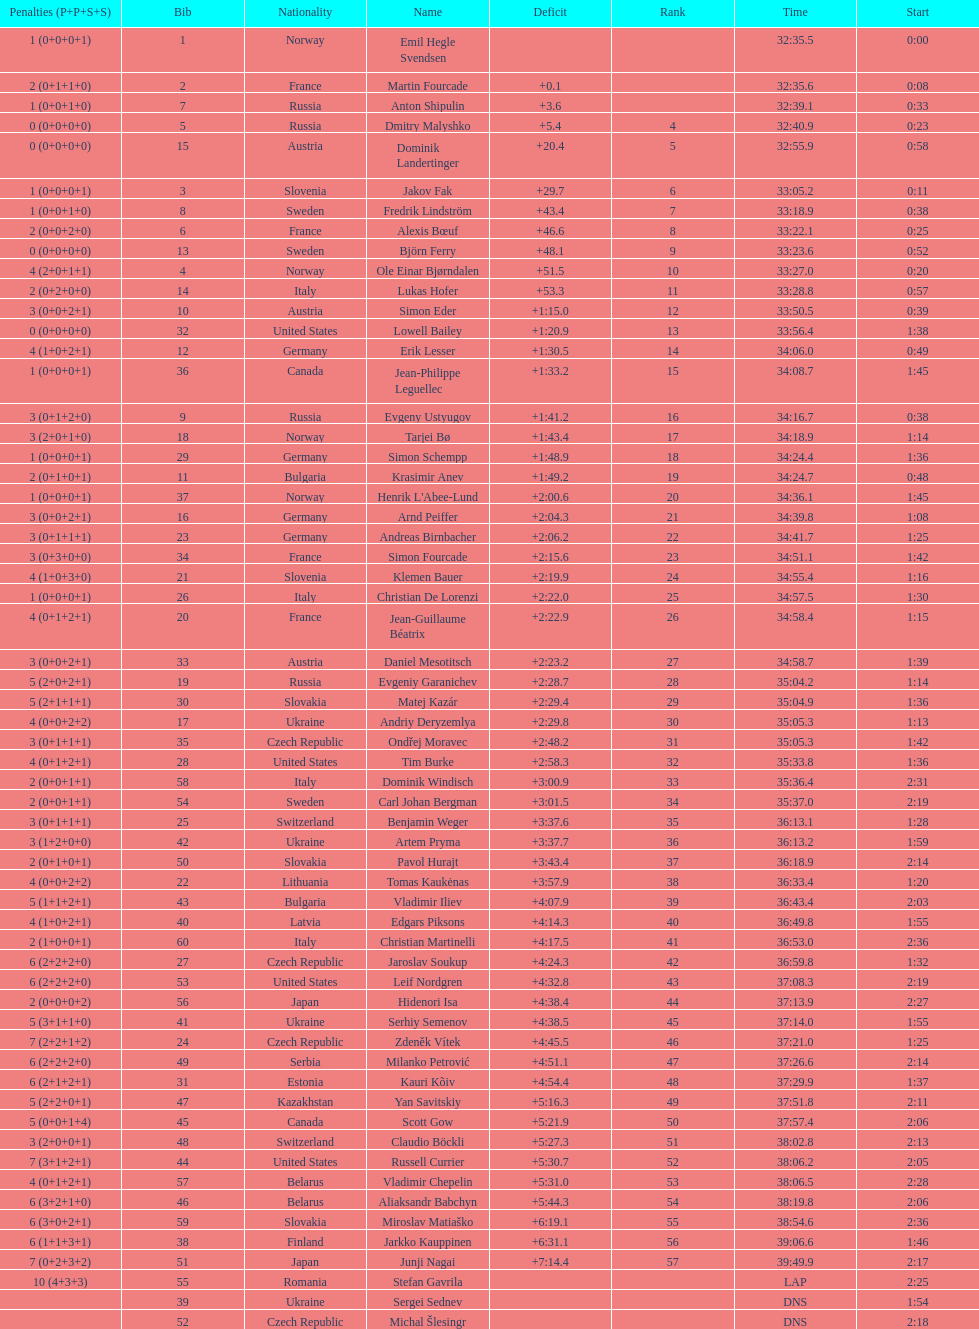What is the total number of participants between norway and france? 7. 